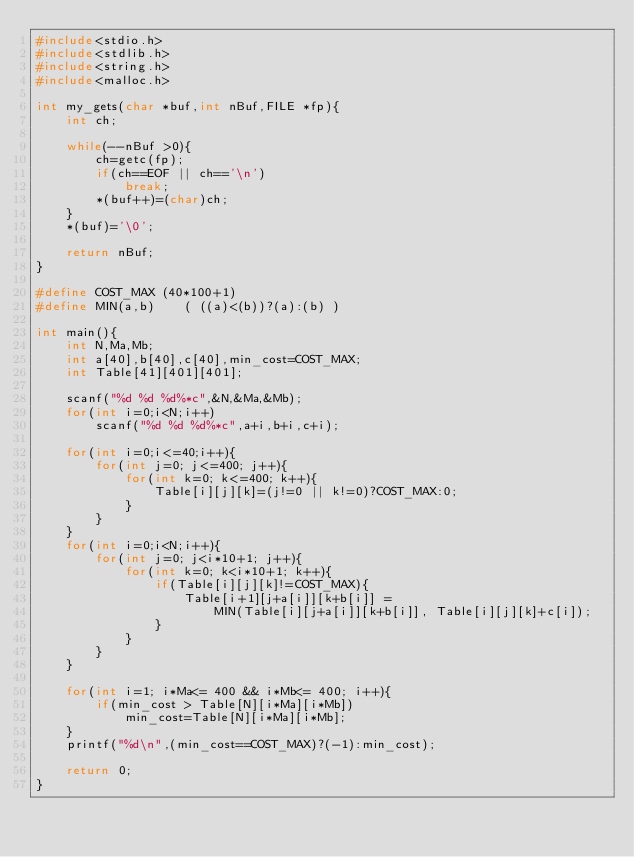<code> <loc_0><loc_0><loc_500><loc_500><_C++_>#include<stdio.h>
#include<stdlib.h>
#include<string.h>
#include<malloc.h>

int my_gets(char *buf,int nBuf,FILE *fp){
    int ch;

    while(--nBuf >0){
        ch=getc(fp);
        if(ch==EOF || ch=='\n')
            break;
        *(buf++)=(char)ch;
    }
    *(buf)='\0';

    return nBuf;
}

#define COST_MAX (40*100+1)
#define MIN(a,b)    ( ((a)<(b))?(a):(b) )

int main(){
    int N,Ma,Mb;
    int a[40],b[40],c[40],min_cost=COST_MAX;
    int Table[41][401][401];

    scanf("%d %d %d%*c",&N,&Ma,&Mb);
    for(int i=0;i<N;i++)
        scanf("%d %d %d%*c",a+i,b+i,c+i);
    
    for(int i=0;i<=40;i++){
        for(int j=0; j<=400; j++){
            for(int k=0; k<=400; k++){
                Table[i][j][k]=(j!=0 || k!=0)?COST_MAX:0;
            }
        }
    }
    for(int i=0;i<N;i++){
        for(int j=0; j<i*10+1; j++){
            for(int k=0; k<i*10+1; k++){
                if(Table[i][j][k]!=COST_MAX){
                    Table[i+1][j+a[i]][k+b[i]] =
                        MIN(Table[i][j+a[i]][k+b[i]], Table[i][j][k]+c[i]);
                }
            }
        }
    }

    for(int i=1; i*Ma<= 400 && i*Mb<= 400; i++){
        if(min_cost > Table[N][i*Ma][i*Mb])
            min_cost=Table[N][i*Ma][i*Mb];
    }
    printf("%d\n",(min_cost==COST_MAX)?(-1):min_cost);
    
    return 0;
}</code> 